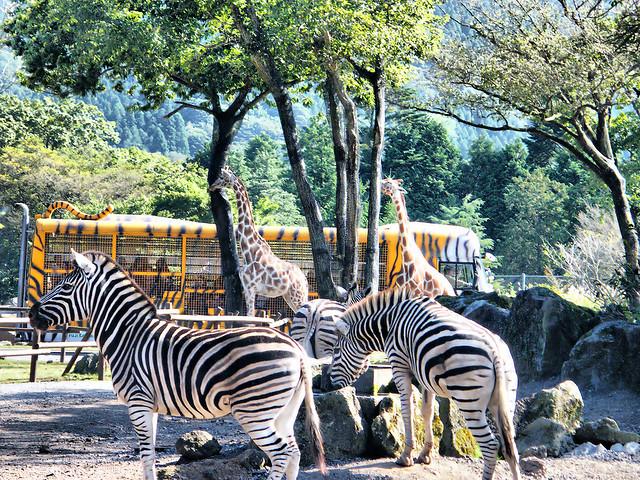How many kinds of animals are in this photo?
Short answer required. 2. Is this a tour bus?
Quick response, please. Yes. Does the bus have a tail?
Concise answer only. Yes. 